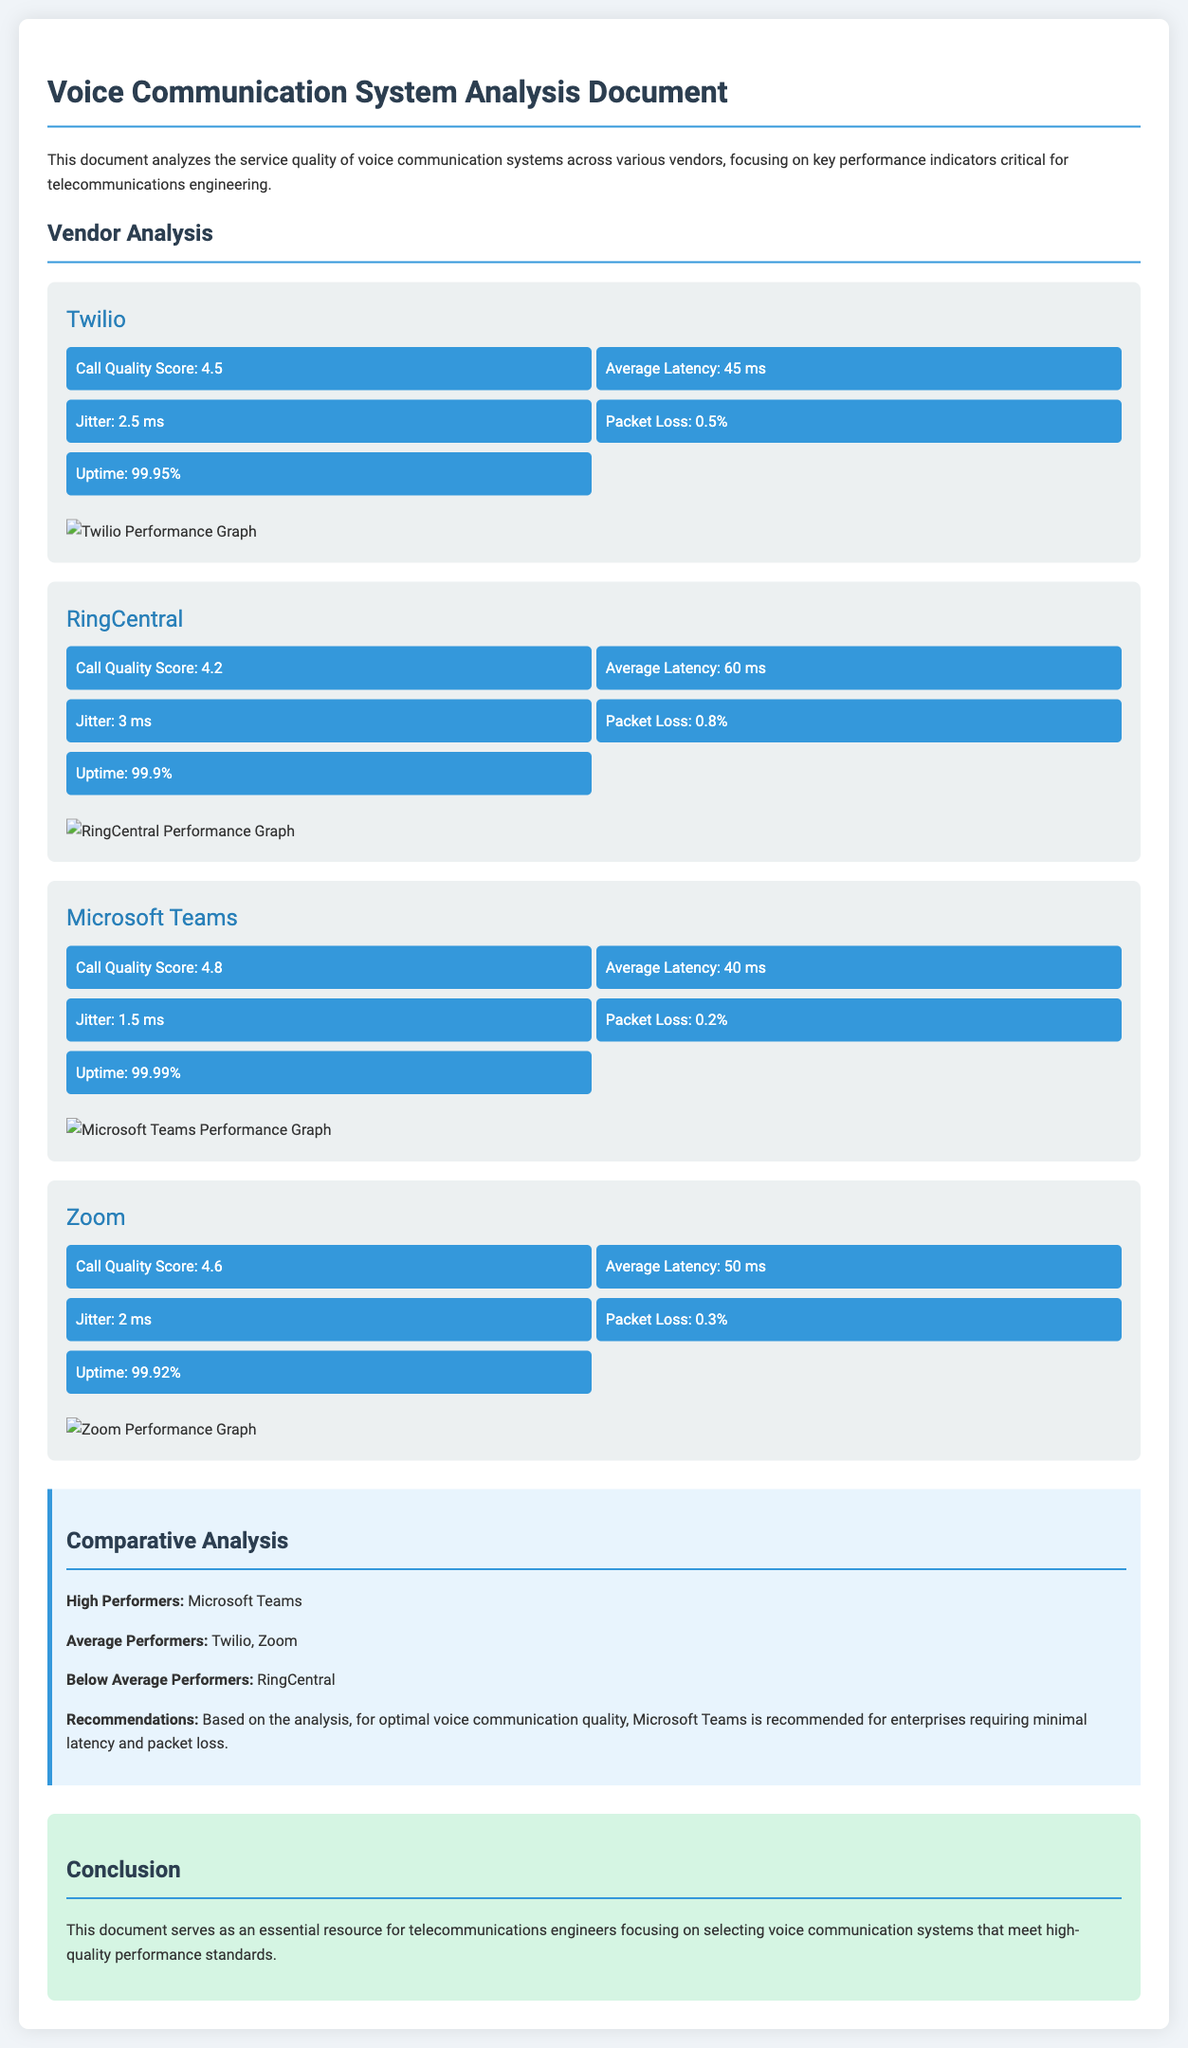What is the Call Quality Score for Twilio? The Call Quality Score for Twilio is indicated in the vendor metrics section of the document.
Answer: 4.5 What vendor has the lowest packet loss? To find the vendor with the lowest packet loss, we can compare the packet loss percentages listed for each vendor.
Answer: Microsoft Teams What is the average latency for Zoom? The average latency for Zoom is specified in the metrics for that vendor.
Answer: 50 ms Which vendor has the highest uptime percentage? The uptime percentages for all vendors can be compared to find the highest value.
Answer: Microsoft Teams What are the below average performers according to the analysis? The analysis section clearly states which vendors fall into the below-average category based on their performance metrics.
Answer: RingCentral How many vendors have a Call Quality Score above 4.5? The document lists the Call Quality Scores for each vendor, allowing us to count those exceeding 4.5.
Answer: 2 Which two vendors fall into the average performers category? The average performers are mentioned in the comparative analysis, allowing us to identify them.
Answer: Twilio, Zoom What is the main recommendation for enterprises regarding voice communication quality? The recommendation given in the document advises on the best vendor for optimal voice communication quality.
Answer: Microsoft Teams 